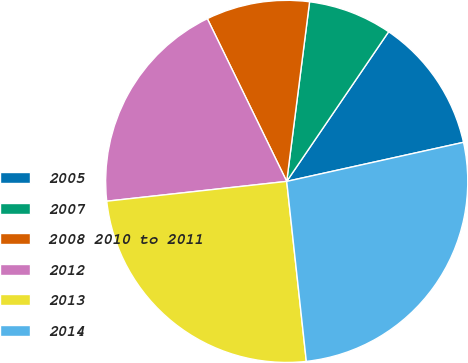<chart> <loc_0><loc_0><loc_500><loc_500><pie_chart><fcel>2005<fcel>2007<fcel>2008 2010 to 2011<fcel>2012<fcel>2013<fcel>2014<nl><fcel>12.02%<fcel>7.5%<fcel>9.24%<fcel>19.52%<fcel>24.98%<fcel>26.73%<nl></chart> 